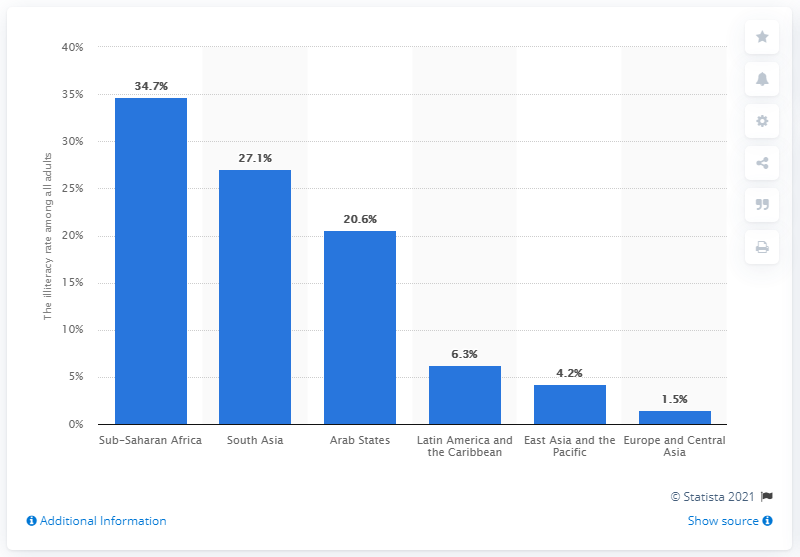List a handful of essential elements in this visual. In 2019, the illiteracy rate among adults aged 15 years and older in Sub-Saharan Africa was 34.7%. In 2019, the illiteracy rate in South Asia was estimated to be 27.1%. This represents a significant decrease from previous years and reflects the ongoing efforts to improve access to education in the region. In 2019, the illiteracy rate in Sub-Saharan Africa was 34.7 percent. 